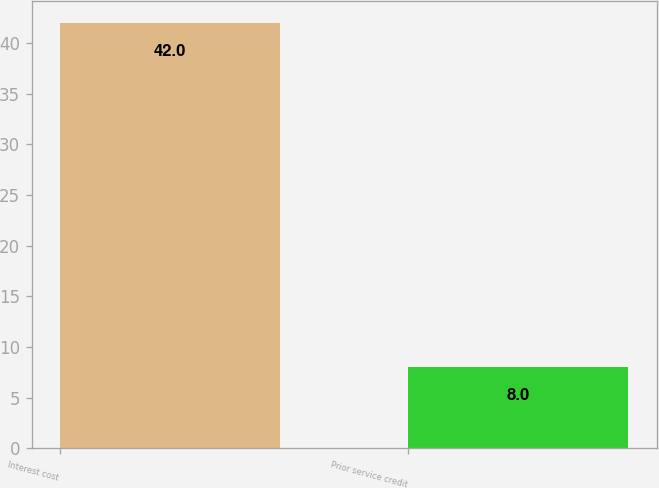Convert chart. <chart><loc_0><loc_0><loc_500><loc_500><bar_chart><fcel>Interest cost<fcel>Prior service credit<nl><fcel>42<fcel>8<nl></chart> 